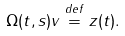<formula> <loc_0><loc_0><loc_500><loc_500>\Omega ( t , s ) v \stackrel { d e f } { = } z ( t ) .</formula> 